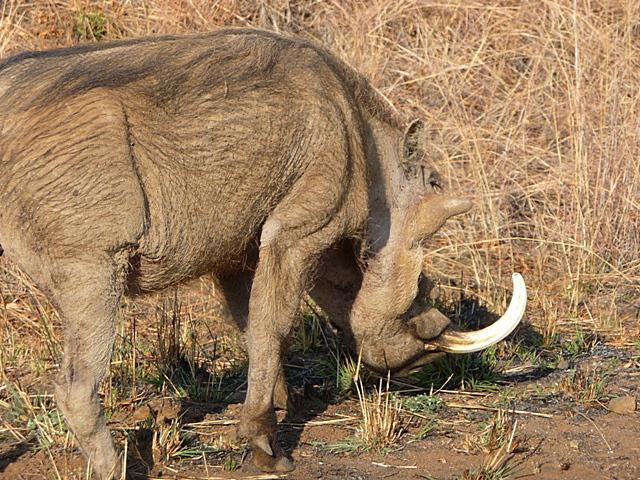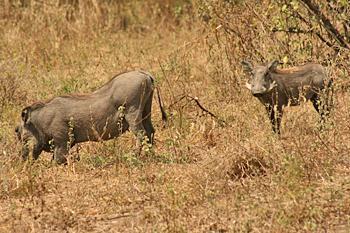The first image is the image on the left, the second image is the image on the right. Analyze the images presented: Is the assertion "warthogs are sitting on bent front legs" valid? Answer yes or no. No. The first image is the image on the left, the second image is the image on the right. Assess this claim about the two images: "A group of four or more animals stands in a field.". Correct or not? Answer yes or no. No. 